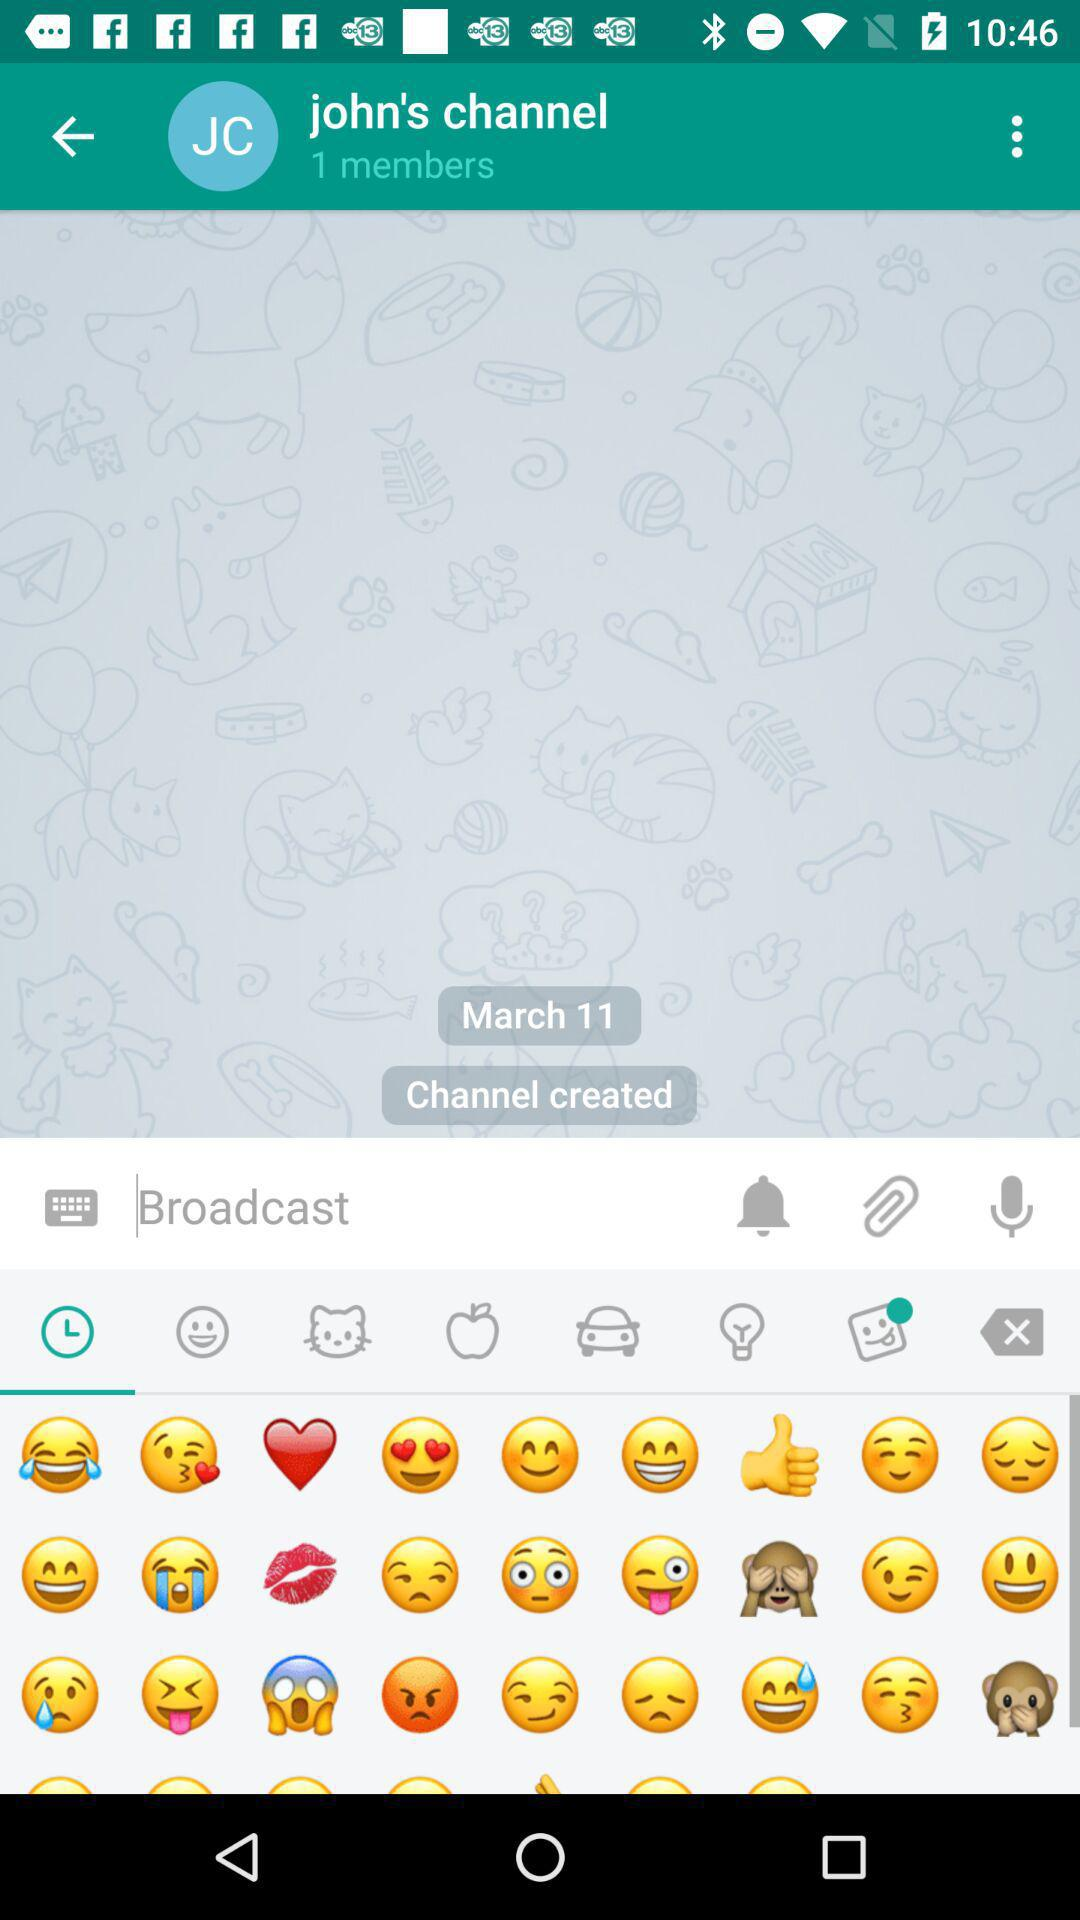How many members are in John's channel? There is 1 member in John's channel. 